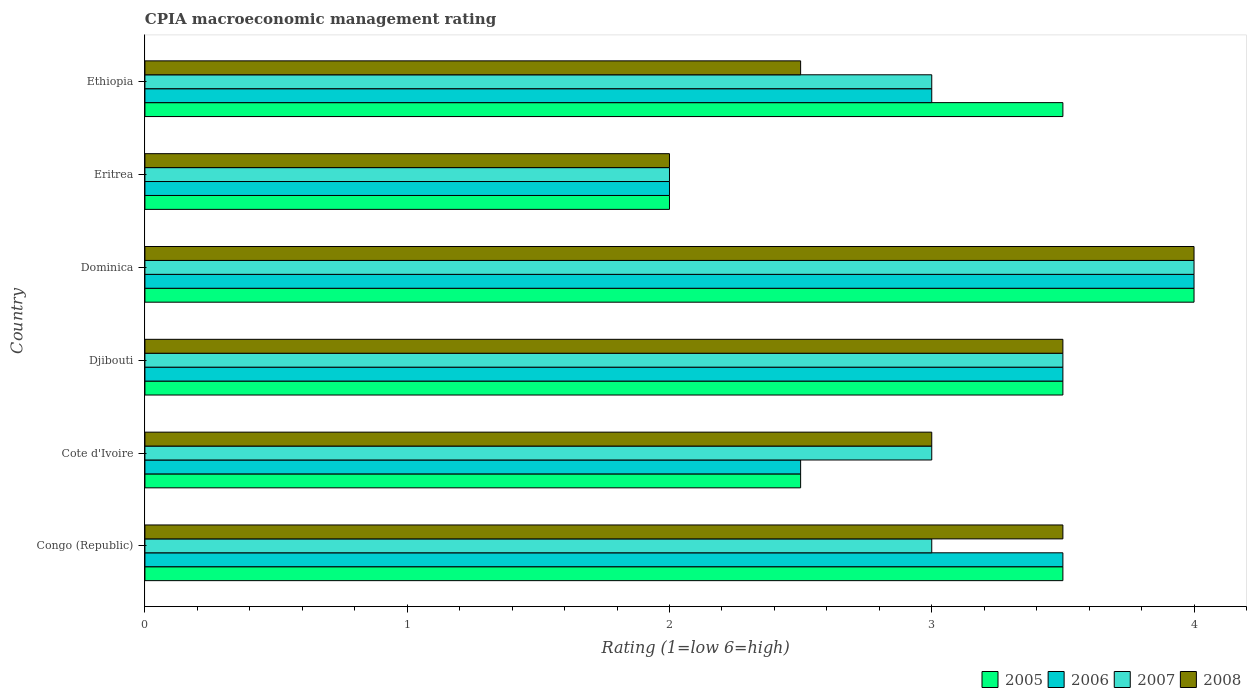How many different coloured bars are there?
Your answer should be compact. 4. How many groups of bars are there?
Keep it short and to the point. 6. Are the number of bars per tick equal to the number of legend labels?
Your response must be concise. Yes. Are the number of bars on each tick of the Y-axis equal?
Your response must be concise. Yes. How many bars are there on the 2nd tick from the top?
Offer a very short reply. 4. How many bars are there on the 5th tick from the bottom?
Your response must be concise. 4. What is the label of the 5th group of bars from the top?
Make the answer very short. Cote d'Ivoire. Across all countries, what is the minimum CPIA rating in 2005?
Offer a very short reply. 2. In which country was the CPIA rating in 2008 maximum?
Give a very brief answer. Dominica. In which country was the CPIA rating in 2008 minimum?
Provide a succinct answer. Eritrea. What is the difference between the CPIA rating in 2008 in Congo (Republic) and that in Cote d'Ivoire?
Provide a short and direct response. 0.5. What is the difference between the CPIA rating in 2005 in Dominica and the CPIA rating in 2007 in Djibouti?
Ensure brevity in your answer.  0.5. What is the average CPIA rating in 2005 per country?
Provide a succinct answer. 3.17. What is the difference between the CPIA rating in 2007 and CPIA rating in 2005 in Ethiopia?
Your answer should be very brief. -0.5. In how many countries, is the CPIA rating in 2005 greater than 1.2 ?
Your answer should be very brief. 6. What is the ratio of the CPIA rating in 2005 in Eritrea to that in Ethiopia?
Offer a terse response. 0.57. Is the CPIA rating in 2005 in Congo (Republic) less than that in Eritrea?
Provide a succinct answer. No. Is the difference between the CPIA rating in 2007 in Eritrea and Ethiopia greater than the difference between the CPIA rating in 2005 in Eritrea and Ethiopia?
Offer a terse response. Yes. What is the difference between the highest and the second highest CPIA rating in 2008?
Keep it short and to the point. 0.5. What is the difference between the highest and the lowest CPIA rating in 2005?
Your answer should be compact. 2. Is the sum of the CPIA rating in 2005 in Eritrea and Ethiopia greater than the maximum CPIA rating in 2006 across all countries?
Offer a very short reply. Yes. Is it the case that in every country, the sum of the CPIA rating in 2005 and CPIA rating in 2006 is greater than the CPIA rating in 2007?
Give a very brief answer. Yes. Are the values on the major ticks of X-axis written in scientific E-notation?
Provide a short and direct response. No. Does the graph contain grids?
Offer a very short reply. No. How many legend labels are there?
Provide a succinct answer. 4. How are the legend labels stacked?
Offer a very short reply. Horizontal. What is the title of the graph?
Offer a terse response. CPIA macroeconomic management rating. Does "1982" appear as one of the legend labels in the graph?
Ensure brevity in your answer.  No. What is the label or title of the X-axis?
Offer a terse response. Rating (1=low 6=high). What is the Rating (1=low 6=high) of 2007 in Congo (Republic)?
Your response must be concise. 3. What is the Rating (1=low 6=high) of 2008 in Congo (Republic)?
Give a very brief answer. 3.5. What is the Rating (1=low 6=high) of 2006 in Cote d'Ivoire?
Provide a short and direct response. 2.5. What is the Rating (1=low 6=high) of 2008 in Cote d'Ivoire?
Ensure brevity in your answer.  3. What is the Rating (1=low 6=high) in 2006 in Djibouti?
Provide a short and direct response. 3.5. What is the Rating (1=low 6=high) in 2007 in Djibouti?
Ensure brevity in your answer.  3.5. What is the Rating (1=low 6=high) of 2005 in Dominica?
Make the answer very short. 4. What is the Rating (1=low 6=high) of 2007 in Eritrea?
Keep it short and to the point. 2. What is the Rating (1=low 6=high) of 2008 in Eritrea?
Your answer should be very brief. 2. What is the Rating (1=low 6=high) in 2007 in Ethiopia?
Your answer should be compact. 3. Across all countries, what is the maximum Rating (1=low 6=high) in 2006?
Make the answer very short. 4. Across all countries, what is the maximum Rating (1=low 6=high) of 2007?
Give a very brief answer. 4. Across all countries, what is the maximum Rating (1=low 6=high) of 2008?
Provide a succinct answer. 4. Across all countries, what is the minimum Rating (1=low 6=high) of 2007?
Offer a terse response. 2. What is the total Rating (1=low 6=high) of 2005 in the graph?
Provide a short and direct response. 19. What is the total Rating (1=low 6=high) in 2006 in the graph?
Your answer should be compact. 18.5. What is the difference between the Rating (1=low 6=high) in 2005 in Congo (Republic) and that in Cote d'Ivoire?
Ensure brevity in your answer.  1. What is the difference between the Rating (1=low 6=high) of 2008 in Congo (Republic) and that in Cote d'Ivoire?
Your answer should be compact. 0.5. What is the difference between the Rating (1=low 6=high) in 2005 in Congo (Republic) and that in Djibouti?
Give a very brief answer. 0. What is the difference between the Rating (1=low 6=high) of 2007 in Congo (Republic) and that in Djibouti?
Your response must be concise. -0.5. What is the difference between the Rating (1=low 6=high) of 2008 in Congo (Republic) and that in Djibouti?
Keep it short and to the point. 0. What is the difference between the Rating (1=low 6=high) of 2006 in Congo (Republic) and that in Dominica?
Make the answer very short. -0.5. What is the difference between the Rating (1=low 6=high) of 2007 in Congo (Republic) and that in Dominica?
Offer a very short reply. -1. What is the difference between the Rating (1=low 6=high) in 2007 in Congo (Republic) and that in Eritrea?
Your response must be concise. 1. What is the difference between the Rating (1=low 6=high) in 2006 in Congo (Republic) and that in Ethiopia?
Your response must be concise. 0.5. What is the difference between the Rating (1=low 6=high) of 2005 in Cote d'Ivoire and that in Djibouti?
Your answer should be compact. -1. What is the difference between the Rating (1=low 6=high) in 2007 in Cote d'Ivoire and that in Djibouti?
Make the answer very short. -0.5. What is the difference between the Rating (1=low 6=high) of 2008 in Cote d'Ivoire and that in Djibouti?
Keep it short and to the point. -0.5. What is the difference between the Rating (1=low 6=high) in 2006 in Cote d'Ivoire and that in Dominica?
Give a very brief answer. -1.5. What is the difference between the Rating (1=low 6=high) of 2007 in Cote d'Ivoire and that in Dominica?
Your answer should be very brief. -1. What is the difference between the Rating (1=low 6=high) in 2005 in Cote d'Ivoire and that in Eritrea?
Provide a succinct answer. 0.5. What is the difference between the Rating (1=low 6=high) in 2007 in Cote d'Ivoire and that in Eritrea?
Make the answer very short. 1. What is the difference between the Rating (1=low 6=high) of 2005 in Cote d'Ivoire and that in Ethiopia?
Provide a short and direct response. -1. What is the difference between the Rating (1=low 6=high) of 2006 in Cote d'Ivoire and that in Ethiopia?
Your response must be concise. -0.5. What is the difference between the Rating (1=low 6=high) in 2008 in Cote d'Ivoire and that in Ethiopia?
Your response must be concise. 0.5. What is the difference between the Rating (1=low 6=high) in 2008 in Djibouti and that in Dominica?
Keep it short and to the point. -0.5. What is the difference between the Rating (1=low 6=high) of 2006 in Djibouti and that in Eritrea?
Provide a succinct answer. 1.5. What is the difference between the Rating (1=low 6=high) of 2008 in Djibouti and that in Eritrea?
Offer a very short reply. 1.5. What is the difference between the Rating (1=low 6=high) of 2007 in Djibouti and that in Ethiopia?
Make the answer very short. 0.5. What is the difference between the Rating (1=low 6=high) in 2008 in Djibouti and that in Ethiopia?
Give a very brief answer. 1. What is the difference between the Rating (1=low 6=high) of 2008 in Dominica and that in Eritrea?
Give a very brief answer. 2. What is the difference between the Rating (1=low 6=high) of 2006 in Dominica and that in Ethiopia?
Your answer should be compact. 1. What is the difference between the Rating (1=low 6=high) in 2008 in Dominica and that in Ethiopia?
Your answer should be very brief. 1.5. What is the difference between the Rating (1=low 6=high) in 2005 in Eritrea and that in Ethiopia?
Your answer should be compact. -1.5. What is the difference between the Rating (1=low 6=high) in 2007 in Eritrea and that in Ethiopia?
Make the answer very short. -1. What is the difference between the Rating (1=low 6=high) in 2008 in Eritrea and that in Ethiopia?
Keep it short and to the point. -0.5. What is the difference between the Rating (1=low 6=high) in 2005 in Congo (Republic) and the Rating (1=low 6=high) in 2007 in Cote d'Ivoire?
Ensure brevity in your answer.  0.5. What is the difference between the Rating (1=low 6=high) of 2006 in Congo (Republic) and the Rating (1=low 6=high) of 2008 in Cote d'Ivoire?
Ensure brevity in your answer.  0.5. What is the difference between the Rating (1=low 6=high) of 2007 in Congo (Republic) and the Rating (1=low 6=high) of 2008 in Cote d'Ivoire?
Provide a short and direct response. 0. What is the difference between the Rating (1=low 6=high) in 2005 in Congo (Republic) and the Rating (1=low 6=high) in 2006 in Djibouti?
Keep it short and to the point. 0. What is the difference between the Rating (1=low 6=high) of 2005 in Congo (Republic) and the Rating (1=low 6=high) of 2007 in Djibouti?
Give a very brief answer. 0. What is the difference between the Rating (1=low 6=high) in 2005 in Congo (Republic) and the Rating (1=low 6=high) in 2008 in Djibouti?
Offer a very short reply. 0. What is the difference between the Rating (1=low 6=high) of 2006 in Congo (Republic) and the Rating (1=low 6=high) of 2008 in Djibouti?
Your answer should be very brief. 0. What is the difference between the Rating (1=low 6=high) in 2007 in Congo (Republic) and the Rating (1=low 6=high) in 2008 in Djibouti?
Offer a very short reply. -0.5. What is the difference between the Rating (1=low 6=high) in 2005 in Congo (Republic) and the Rating (1=low 6=high) in 2006 in Dominica?
Provide a short and direct response. -0.5. What is the difference between the Rating (1=low 6=high) in 2005 in Congo (Republic) and the Rating (1=low 6=high) in 2007 in Dominica?
Offer a terse response. -0.5. What is the difference between the Rating (1=low 6=high) in 2005 in Congo (Republic) and the Rating (1=low 6=high) in 2008 in Dominica?
Ensure brevity in your answer.  -0.5. What is the difference between the Rating (1=low 6=high) in 2006 in Congo (Republic) and the Rating (1=low 6=high) in 2007 in Dominica?
Offer a very short reply. -0.5. What is the difference between the Rating (1=low 6=high) in 2006 in Congo (Republic) and the Rating (1=low 6=high) in 2008 in Dominica?
Your answer should be compact. -0.5. What is the difference between the Rating (1=low 6=high) in 2005 in Congo (Republic) and the Rating (1=low 6=high) in 2006 in Eritrea?
Your response must be concise. 1.5. What is the difference between the Rating (1=low 6=high) in 2005 in Congo (Republic) and the Rating (1=low 6=high) in 2007 in Eritrea?
Offer a terse response. 1.5. What is the difference between the Rating (1=low 6=high) of 2006 in Congo (Republic) and the Rating (1=low 6=high) of 2008 in Eritrea?
Your response must be concise. 1.5. What is the difference between the Rating (1=low 6=high) in 2007 in Congo (Republic) and the Rating (1=low 6=high) in 2008 in Eritrea?
Give a very brief answer. 1. What is the difference between the Rating (1=low 6=high) in 2006 in Congo (Republic) and the Rating (1=low 6=high) in 2007 in Ethiopia?
Your answer should be compact. 0.5. What is the difference between the Rating (1=low 6=high) in 2006 in Congo (Republic) and the Rating (1=low 6=high) in 2008 in Ethiopia?
Offer a very short reply. 1. What is the difference between the Rating (1=low 6=high) in 2005 in Cote d'Ivoire and the Rating (1=low 6=high) in 2006 in Djibouti?
Provide a succinct answer. -1. What is the difference between the Rating (1=low 6=high) of 2005 in Cote d'Ivoire and the Rating (1=low 6=high) of 2008 in Djibouti?
Keep it short and to the point. -1. What is the difference between the Rating (1=low 6=high) in 2006 in Cote d'Ivoire and the Rating (1=low 6=high) in 2007 in Djibouti?
Make the answer very short. -1. What is the difference between the Rating (1=low 6=high) of 2007 in Cote d'Ivoire and the Rating (1=low 6=high) of 2008 in Djibouti?
Provide a short and direct response. -0.5. What is the difference between the Rating (1=low 6=high) in 2005 in Cote d'Ivoire and the Rating (1=low 6=high) in 2006 in Dominica?
Your answer should be very brief. -1.5. What is the difference between the Rating (1=low 6=high) in 2005 in Cote d'Ivoire and the Rating (1=low 6=high) in 2007 in Dominica?
Ensure brevity in your answer.  -1.5. What is the difference between the Rating (1=low 6=high) of 2005 in Cote d'Ivoire and the Rating (1=low 6=high) of 2008 in Dominica?
Provide a short and direct response. -1.5. What is the difference between the Rating (1=low 6=high) of 2005 in Cote d'Ivoire and the Rating (1=low 6=high) of 2006 in Eritrea?
Give a very brief answer. 0.5. What is the difference between the Rating (1=low 6=high) in 2005 in Cote d'Ivoire and the Rating (1=low 6=high) in 2007 in Eritrea?
Make the answer very short. 0.5. What is the difference between the Rating (1=low 6=high) in 2007 in Cote d'Ivoire and the Rating (1=low 6=high) in 2008 in Eritrea?
Provide a succinct answer. 1. What is the difference between the Rating (1=low 6=high) in 2005 in Cote d'Ivoire and the Rating (1=low 6=high) in 2007 in Ethiopia?
Provide a short and direct response. -0.5. What is the difference between the Rating (1=low 6=high) in 2005 in Cote d'Ivoire and the Rating (1=low 6=high) in 2008 in Ethiopia?
Offer a very short reply. 0. What is the difference between the Rating (1=low 6=high) in 2006 in Cote d'Ivoire and the Rating (1=low 6=high) in 2008 in Ethiopia?
Give a very brief answer. 0. What is the difference between the Rating (1=low 6=high) of 2007 in Cote d'Ivoire and the Rating (1=low 6=high) of 2008 in Ethiopia?
Your response must be concise. 0.5. What is the difference between the Rating (1=low 6=high) in 2006 in Djibouti and the Rating (1=low 6=high) in 2008 in Dominica?
Your answer should be compact. -0.5. What is the difference between the Rating (1=low 6=high) of 2007 in Djibouti and the Rating (1=low 6=high) of 2008 in Dominica?
Give a very brief answer. -0.5. What is the difference between the Rating (1=low 6=high) in 2005 in Djibouti and the Rating (1=low 6=high) in 2006 in Eritrea?
Offer a very short reply. 1.5. What is the difference between the Rating (1=low 6=high) of 2005 in Djibouti and the Rating (1=low 6=high) of 2008 in Eritrea?
Provide a succinct answer. 1.5. What is the difference between the Rating (1=low 6=high) of 2006 in Djibouti and the Rating (1=low 6=high) of 2007 in Eritrea?
Keep it short and to the point. 1.5. What is the difference between the Rating (1=low 6=high) in 2006 in Djibouti and the Rating (1=low 6=high) in 2008 in Eritrea?
Ensure brevity in your answer.  1.5. What is the difference between the Rating (1=low 6=high) of 2005 in Djibouti and the Rating (1=low 6=high) of 2006 in Ethiopia?
Give a very brief answer. 0.5. What is the difference between the Rating (1=low 6=high) of 2005 in Djibouti and the Rating (1=low 6=high) of 2007 in Ethiopia?
Provide a short and direct response. 0.5. What is the difference between the Rating (1=low 6=high) of 2005 in Djibouti and the Rating (1=low 6=high) of 2008 in Ethiopia?
Ensure brevity in your answer.  1. What is the difference between the Rating (1=low 6=high) of 2006 in Djibouti and the Rating (1=low 6=high) of 2007 in Ethiopia?
Your answer should be compact. 0.5. What is the difference between the Rating (1=low 6=high) of 2006 in Djibouti and the Rating (1=low 6=high) of 2008 in Ethiopia?
Ensure brevity in your answer.  1. What is the difference between the Rating (1=low 6=high) of 2005 in Dominica and the Rating (1=low 6=high) of 2008 in Eritrea?
Make the answer very short. 2. What is the difference between the Rating (1=low 6=high) in 2007 in Dominica and the Rating (1=low 6=high) in 2008 in Eritrea?
Provide a succinct answer. 2. What is the difference between the Rating (1=low 6=high) in 2005 in Dominica and the Rating (1=low 6=high) in 2007 in Ethiopia?
Ensure brevity in your answer.  1. What is the difference between the Rating (1=low 6=high) in 2005 in Dominica and the Rating (1=low 6=high) in 2008 in Ethiopia?
Make the answer very short. 1.5. What is the difference between the Rating (1=low 6=high) in 2006 in Dominica and the Rating (1=low 6=high) in 2007 in Ethiopia?
Your answer should be compact. 1. What is the difference between the Rating (1=low 6=high) in 2007 in Dominica and the Rating (1=low 6=high) in 2008 in Ethiopia?
Your answer should be compact. 1.5. What is the difference between the Rating (1=low 6=high) in 2005 in Eritrea and the Rating (1=low 6=high) in 2007 in Ethiopia?
Provide a succinct answer. -1. What is the difference between the Rating (1=low 6=high) in 2006 in Eritrea and the Rating (1=low 6=high) in 2008 in Ethiopia?
Ensure brevity in your answer.  -0.5. What is the difference between the Rating (1=low 6=high) in 2007 in Eritrea and the Rating (1=low 6=high) in 2008 in Ethiopia?
Provide a short and direct response. -0.5. What is the average Rating (1=low 6=high) of 2005 per country?
Offer a very short reply. 3.17. What is the average Rating (1=low 6=high) of 2006 per country?
Offer a very short reply. 3.08. What is the average Rating (1=low 6=high) in 2007 per country?
Provide a short and direct response. 3.08. What is the average Rating (1=low 6=high) of 2008 per country?
Your answer should be very brief. 3.08. What is the difference between the Rating (1=low 6=high) of 2005 and Rating (1=low 6=high) of 2007 in Congo (Republic)?
Offer a terse response. 0.5. What is the difference between the Rating (1=low 6=high) in 2006 and Rating (1=low 6=high) in 2007 in Congo (Republic)?
Provide a succinct answer. 0.5. What is the difference between the Rating (1=low 6=high) of 2005 and Rating (1=low 6=high) of 2006 in Cote d'Ivoire?
Give a very brief answer. 0. What is the difference between the Rating (1=low 6=high) of 2005 and Rating (1=low 6=high) of 2008 in Cote d'Ivoire?
Offer a very short reply. -0.5. What is the difference between the Rating (1=low 6=high) in 2006 and Rating (1=low 6=high) in 2008 in Cote d'Ivoire?
Make the answer very short. -0.5. What is the difference between the Rating (1=low 6=high) in 2005 and Rating (1=low 6=high) in 2006 in Djibouti?
Ensure brevity in your answer.  0. What is the difference between the Rating (1=low 6=high) in 2005 and Rating (1=low 6=high) in 2007 in Djibouti?
Ensure brevity in your answer.  0. What is the difference between the Rating (1=low 6=high) of 2005 and Rating (1=low 6=high) of 2008 in Djibouti?
Offer a very short reply. 0. What is the difference between the Rating (1=low 6=high) in 2006 and Rating (1=low 6=high) in 2008 in Djibouti?
Provide a short and direct response. 0. What is the difference between the Rating (1=low 6=high) in 2005 and Rating (1=low 6=high) in 2006 in Dominica?
Ensure brevity in your answer.  0. What is the difference between the Rating (1=low 6=high) in 2005 and Rating (1=low 6=high) in 2008 in Dominica?
Offer a terse response. 0. What is the difference between the Rating (1=low 6=high) of 2006 and Rating (1=low 6=high) of 2007 in Dominica?
Your response must be concise. 0. What is the difference between the Rating (1=low 6=high) in 2006 and Rating (1=low 6=high) in 2008 in Dominica?
Provide a succinct answer. 0. What is the difference between the Rating (1=low 6=high) in 2005 and Rating (1=low 6=high) in 2006 in Eritrea?
Your answer should be compact. 0. What is the difference between the Rating (1=low 6=high) of 2005 and Rating (1=low 6=high) of 2007 in Eritrea?
Ensure brevity in your answer.  0. What is the difference between the Rating (1=low 6=high) of 2005 and Rating (1=low 6=high) of 2008 in Eritrea?
Keep it short and to the point. 0. What is the difference between the Rating (1=low 6=high) of 2006 and Rating (1=low 6=high) of 2008 in Eritrea?
Your answer should be compact. 0. What is the difference between the Rating (1=low 6=high) of 2005 and Rating (1=low 6=high) of 2007 in Ethiopia?
Offer a very short reply. 0.5. What is the difference between the Rating (1=low 6=high) in 2006 and Rating (1=low 6=high) in 2007 in Ethiopia?
Offer a very short reply. 0. What is the ratio of the Rating (1=low 6=high) of 2005 in Congo (Republic) to that in Cote d'Ivoire?
Your answer should be very brief. 1.4. What is the ratio of the Rating (1=low 6=high) of 2005 in Congo (Republic) to that in Djibouti?
Make the answer very short. 1. What is the ratio of the Rating (1=low 6=high) in 2008 in Congo (Republic) to that in Djibouti?
Ensure brevity in your answer.  1. What is the ratio of the Rating (1=low 6=high) in 2007 in Congo (Republic) to that in Dominica?
Ensure brevity in your answer.  0.75. What is the ratio of the Rating (1=low 6=high) in 2007 in Congo (Republic) to that in Eritrea?
Give a very brief answer. 1.5. What is the ratio of the Rating (1=low 6=high) in 2008 in Congo (Republic) to that in Eritrea?
Offer a terse response. 1.75. What is the ratio of the Rating (1=low 6=high) of 2006 in Congo (Republic) to that in Ethiopia?
Offer a very short reply. 1.17. What is the ratio of the Rating (1=low 6=high) of 2007 in Congo (Republic) to that in Ethiopia?
Your answer should be very brief. 1. What is the ratio of the Rating (1=low 6=high) of 2008 in Congo (Republic) to that in Ethiopia?
Ensure brevity in your answer.  1.4. What is the ratio of the Rating (1=low 6=high) in 2005 in Cote d'Ivoire to that in Djibouti?
Provide a short and direct response. 0.71. What is the ratio of the Rating (1=low 6=high) in 2007 in Cote d'Ivoire to that in Djibouti?
Give a very brief answer. 0.86. What is the ratio of the Rating (1=low 6=high) in 2006 in Cote d'Ivoire to that in Dominica?
Make the answer very short. 0.62. What is the ratio of the Rating (1=low 6=high) of 2007 in Cote d'Ivoire to that in Dominica?
Offer a very short reply. 0.75. What is the ratio of the Rating (1=low 6=high) of 2008 in Cote d'Ivoire to that in Dominica?
Keep it short and to the point. 0.75. What is the ratio of the Rating (1=low 6=high) in 2005 in Cote d'Ivoire to that in Eritrea?
Offer a very short reply. 1.25. What is the ratio of the Rating (1=low 6=high) in 2008 in Cote d'Ivoire to that in Eritrea?
Provide a succinct answer. 1.5. What is the ratio of the Rating (1=low 6=high) in 2005 in Cote d'Ivoire to that in Ethiopia?
Provide a short and direct response. 0.71. What is the ratio of the Rating (1=low 6=high) of 2006 in Cote d'Ivoire to that in Ethiopia?
Keep it short and to the point. 0.83. What is the ratio of the Rating (1=low 6=high) of 2007 in Cote d'Ivoire to that in Ethiopia?
Your answer should be very brief. 1. What is the ratio of the Rating (1=low 6=high) in 2005 in Djibouti to that in Dominica?
Make the answer very short. 0.88. What is the ratio of the Rating (1=low 6=high) in 2006 in Djibouti to that in Dominica?
Ensure brevity in your answer.  0.88. What is the ratio of the Rating (1=low 6=high) of 2008 in Djibouti to that in Dominica?
Ensure brevity in your answer.  0.88. What is the ratio of the Rating (1=low 6=high) in 2005 in Djibouti to that in Eritrea?
Your answer should be very brief. 1.75. What is the ratio of the Rating (1=low 6=high) in 2006 in Djibouti to that in Eritrea?
Your answer should be very brief. 1.75. What is the ratio of the Rating (1=low 6=high) in 2008 in Djibouti to that in Eritrea?
Make the answer very short. 1.75. What is the ratio of the Rating (1=low 6=high) of 2006 in Djibouti to that in Ethiopia?
Offer a very short reply. 1.17. What is the ratio of the Rating (1=low 6=high) in 2008 in Djibouti to that in Ethiopia?
Ensure brevity in your answer.  1.4. What is the ratio of the Rating (1=low 6=high) of 2005 in Dominica to that in Eritrea?
Your answer should be very brief. 2. What is the ratio of the Rating (1=low 6=high) of 2006 in Dominica to that in Eritrea?
Make the answer very short. 2. What is the ratio of the Rating (1=low 6=high) of 2007 in Dominica to that in Ethiopia?
Give a very brief answer. 1.33. What is the ratio of the Rating (1=low 6=high) of 2008 in Dominica to that in Ethiopia?
Offer a terse response. 1.6. What is the ratio of the Rating (1=low 6=high) of 2006 in Eritrea to that in Ethiopia?
Your response must be concise. 0.67. What is the ratio of the Rating (1=low 6=high) of 2007 in Eritrea to that in Ethiopia?
Give a very brief answer. 0.67. What is the difference between the highest and the second highest Rating (1=low 6=high) in 2006?
Offer a very short reply. 0.5. What is the difference between the highest and the second highest Rating (1=low 6=high) in 2007?
Your answer should be very brief. 0.5. What is the difference between the highest and the second highest Rating (1=low 6=high) of 2008?
Ensure brevity in your answer.  0.5. What is the difference between the highest and the lowest Rating (1=low 6=high) of 2006?
Your answer should be very brief. 2. What is the difference between the highest and the lowest Rating (1=low 6=high) of 2008?
Keep it short and to the point. 2. 